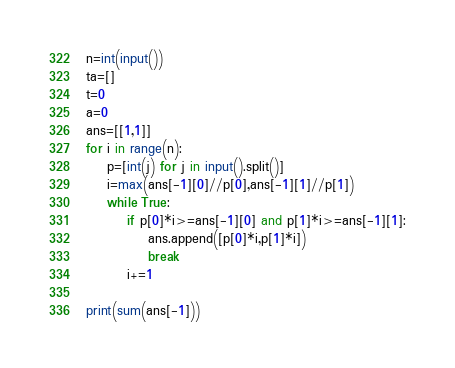Convert code to text. <code><loc_0><loc_0><loc_500><loc_500><_Python_>n=int(input())
ta=[]
t=0
a=0
ans=[[1,1]]
for i in range(n):
    p=[int(j) for j in input().split()]
    i=max(ans[-1][0]//p[0],ans[-1][1]//p[1])
    while True:
        if p[0]*i>=ans[-1][0] and p[1]*i>=ans[-1][1]:
            ans.append([p[0]*i,p[1]*i])
            break
        i+=1

print(sum(ans[-1]))</code> 